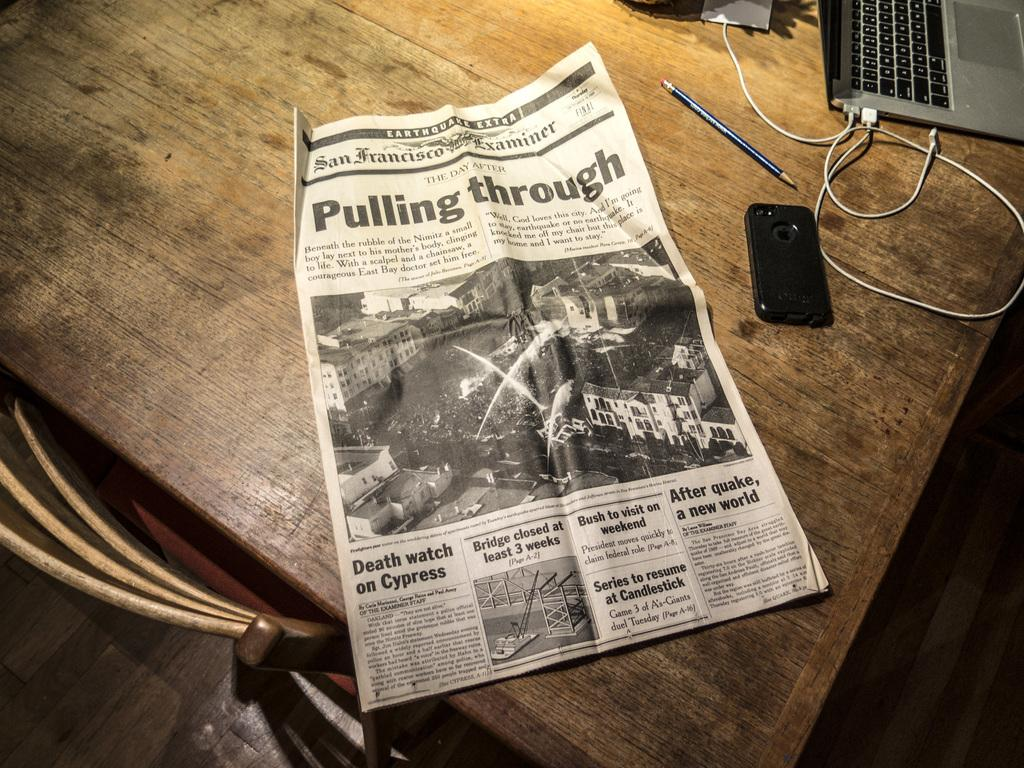Provide a one-sentence caption for the provided image. A newspaper with the headlines of Pulling Through is on a wooden table. 